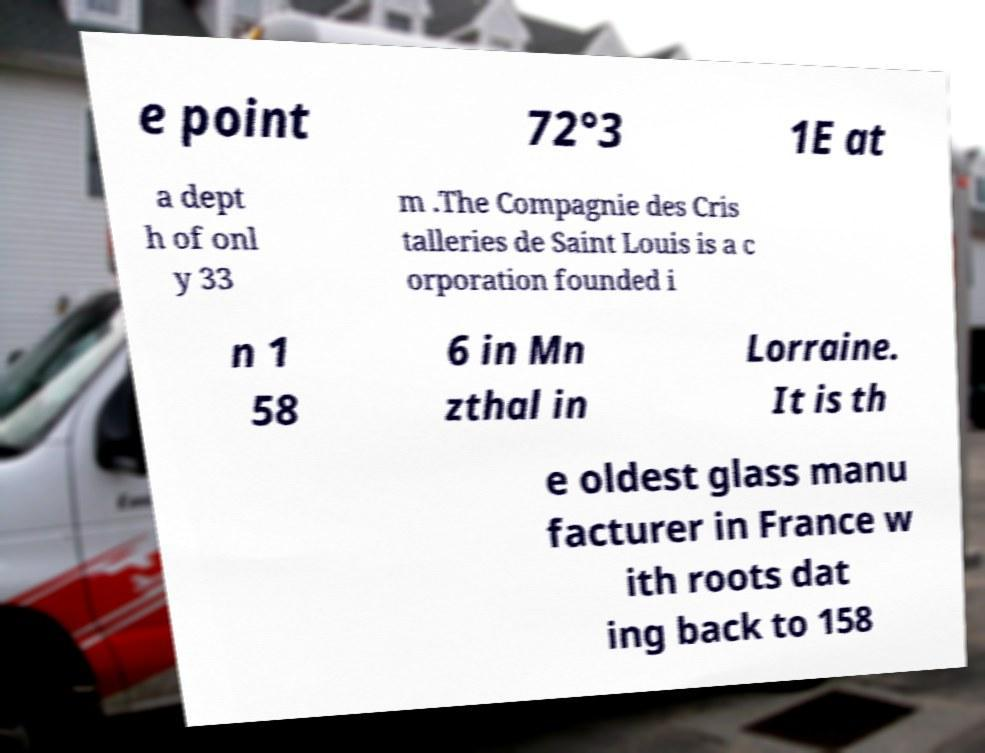What messages or text are displayed in this image? I need them in a readable, typed format. e point 72°3 1E at a dept h of onl y 33 m .The Compagnie des Cris talleries de Saint Louis is a c orporation founded i n 1 58 6 in Mn zthal in Lorraine. It is th e oldest glass manu facturer in France w ith roots dat ing back to 158 